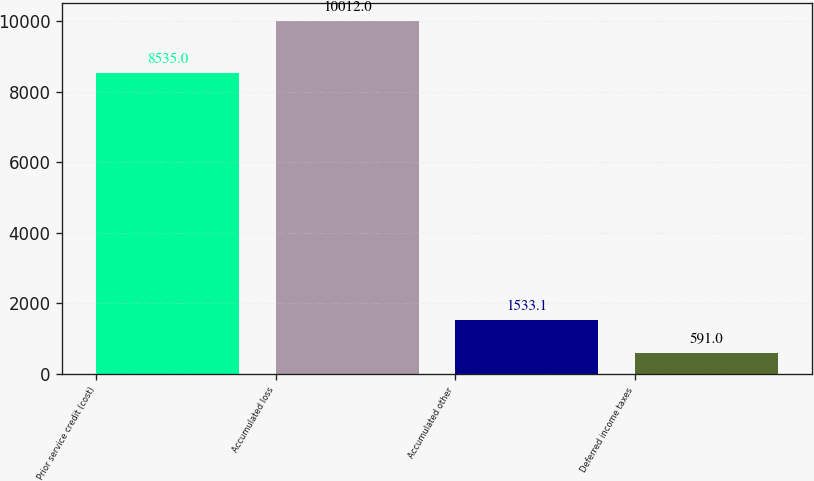<chart> <loc_0><loc_0><loc_500><loc_500><bar_chart><fcel>Prior service credit (cost)<fcel>Accumulated loss<fcel>Accumulated other<fcel>Deferred income taxes<nl><fcel>8535<fcel>10012<fcel>1533.1<fcel>591<nl></chart> 